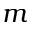Convert formula to latex. <formula><loc_0><loc_0><loc_500><loc_500>m</formula> 